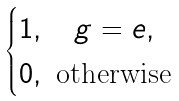Convert formula to latex. <formula><loc_0><loc_0><loc_500><loc_500>\begin{cases} 1 , \quad g = e , \\ 0 , \text { otherwise} \end{cases}</formula> 